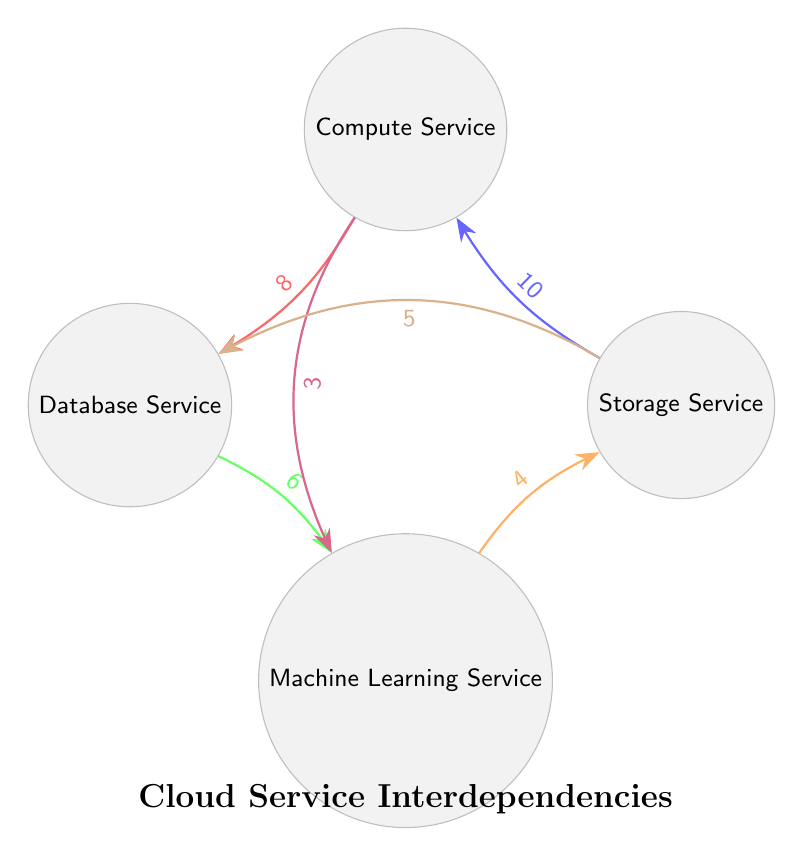What is the total number of nodes in the diagram? The diagram lists four distinct cloud services: Storage Service, Compute Service, Database Service, and Machine Learning Service. Therefore, counting these, we find a total of four nodes.
Answer: 4 Which service has the highest interaction value with the Compute Service? Observing the connections from the Compute Service, it has two interactions: one with the Storage Service (value 10) and another with the Database Service (value 8). The highest value is 10 with Storage Service.
Answer: Storage Service What is the interaction value between the Database Service and the Machine Learning Service? The interaction flows from Database Service to Machine Learning Service with a connection value specified in the diagram. Checking the link, it shows a value of 6 for this interaction.
Answer: 6 How many total interactions does the Machine Learning Service have? The Machine Learning Service has three direct interactions: one with the Database Service (value 6), one with Storage Service (value 4), and one with Compute Service (value 3). Adding these, there are three total interactions.
Answer: 3 Which service does the Compute Service depend on the most? Evaluating the connections related to Compute Service, it relies most heavily on Storage Service since the interaction value (10) is higher than its other connection to Database Service (8) and Machine Learning Service (3).
Answer: Storage Service What is the total value of interactions coming into the Storage Service? To find the total incoming interaction value for the Storage Service, we consider all connections towards it. The values are: from Machine Learning Service (4) and from Compute Service (10). Adding these gives a total of 14.
Answer: 14 Which connection has the lowest interaction value in the diagram? Examining all the connections in the diagram, the link with the lowest value is from Compute Service to Machine Learning Service, which is given as 3.
Answer: 3 What is the total interaction value from Storage Service to Compute Service? The diagram specifies the interaction from Storage Service to Compute Service with a value of 10, which is the only connection between these two nodes. There are no other interactions between them, so it remains 10.
Answer: 10 